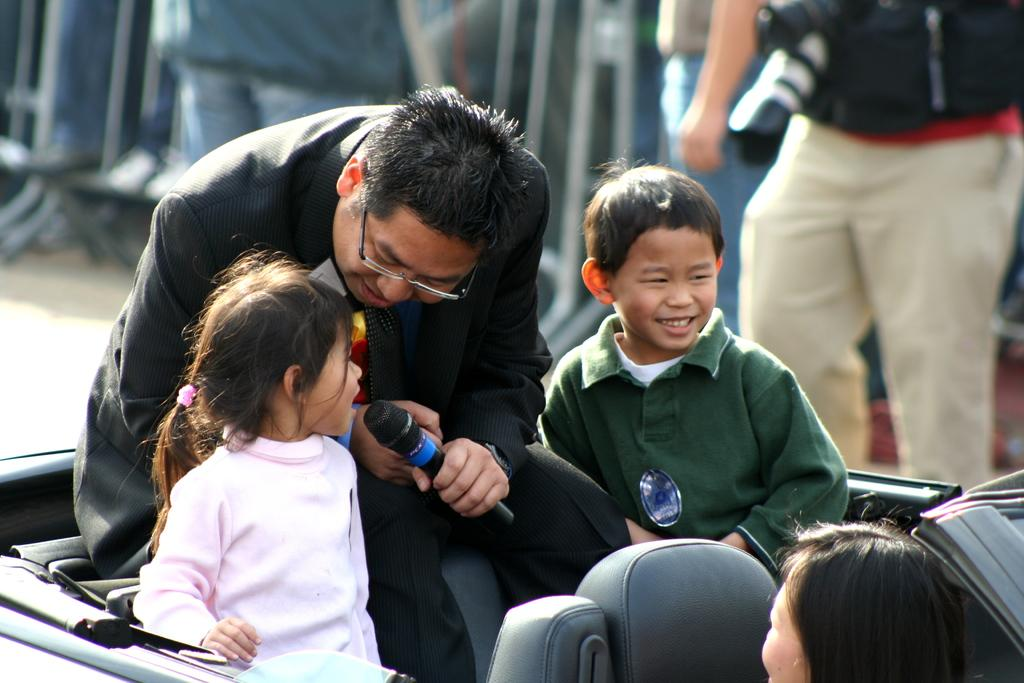What is the person in the image holding? The person is holding a microphone in the image. What can be seen in the foreground of the image? There is a vehicle in the foreground of the image. What is happening with the vehicle in the image? People are on the vehicle in the image. What else can be seen in the image? There are people in the background of the image. What type of pig is visible in the image? There is no pig present in the image. What color is the mint that is being used as a prop in the image? There is no mint present in the image. 